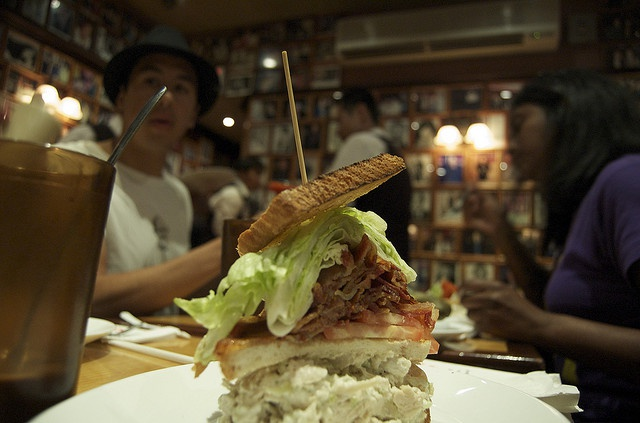Describe the objects in this image and their specific colors. I can see sandwich in black, olive, and maroon tones, people in black and maroon tones, people in black, maroon, and gray tones, cup in black, maroon, and olive tones, and people in black and gray tones in this image. 